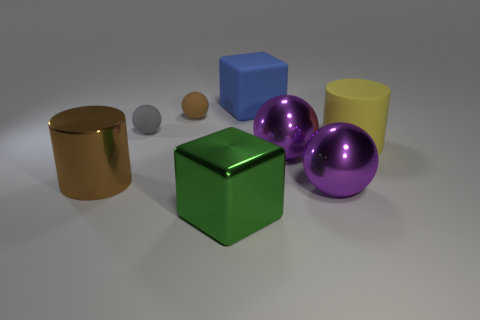There is a brown thing that is the same shape as the tiny gray object; what is its material?
Ensure brevity in your answer.  Rubber. There is a metal object left of the big cube in front of the big cube behind the big yellow thing; what shape is it?
Provide a succinct answer. Cylinder. How many other things are there of the same shape as the small brown object?
Ensure brevity in your answer.  3. There is a metal cylinder; does it have the same color as the ball that is behind the tiny gray thing?
Your answer should be very brief. Yes. How many tiny purple cubes are there?
Give a very brief answer. 0. How many things are either large blue rubber blocks or brown matte spheres?
Offer a terse response. 2. What is the size of the matte thing that is the same color as the big metallic cylinder?
Your answer should be compact. Small. There is a blue rubber object; are there any metal things right of it?
Your response must be concise. Yes. Is the number of metal things that are right of the metal block greater than the number of spheres that are in front of the brown rubber object?
Your response must be concise. No. There is a brown metal object that is the same shape as the yellow rubber thing; what is its size?
Your answer should be very brief. Large. 